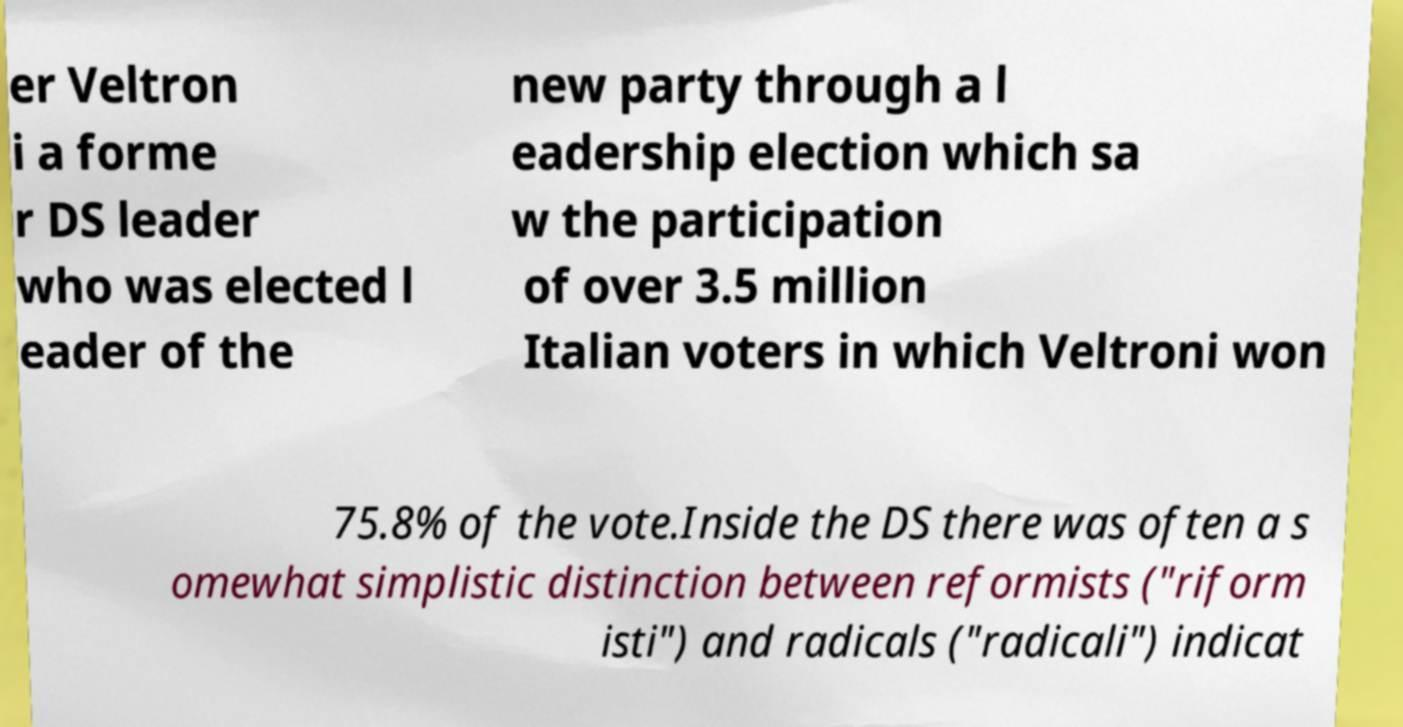Can you accurately transcribe the text from the provided image for me? er Veltron i a forme r DS leader who was elected l eader of the new party through a l eadership election which sa w the participation of over 3.5 million Italian voters in which Veltroni won 75.8% of the vote.Inside the DS there was often a s omewhat simplistic distinction between reformists ("riform isti") and radicals ("radicali") indicat 